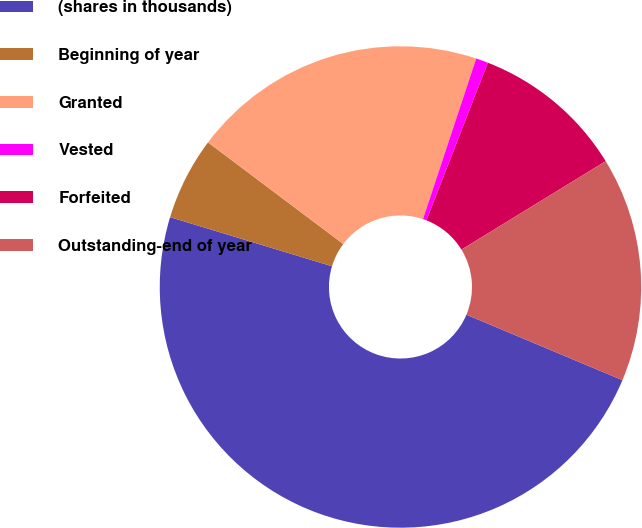<chart> <loc_0><loc_0><loc_500><loc_500><pie_chart><fcel>(shares in thousands)<fcel>Beginning of year<fcel>Granted<fcel>Vested<fcel>Forfeited<fcel>Outstanding-end of year<nl><fcel>48.36%<fcel>5.57%<fcel>19.84%<fcel>0.82%<fcel>10.33%<fcel>15.08%<nl></chart> 